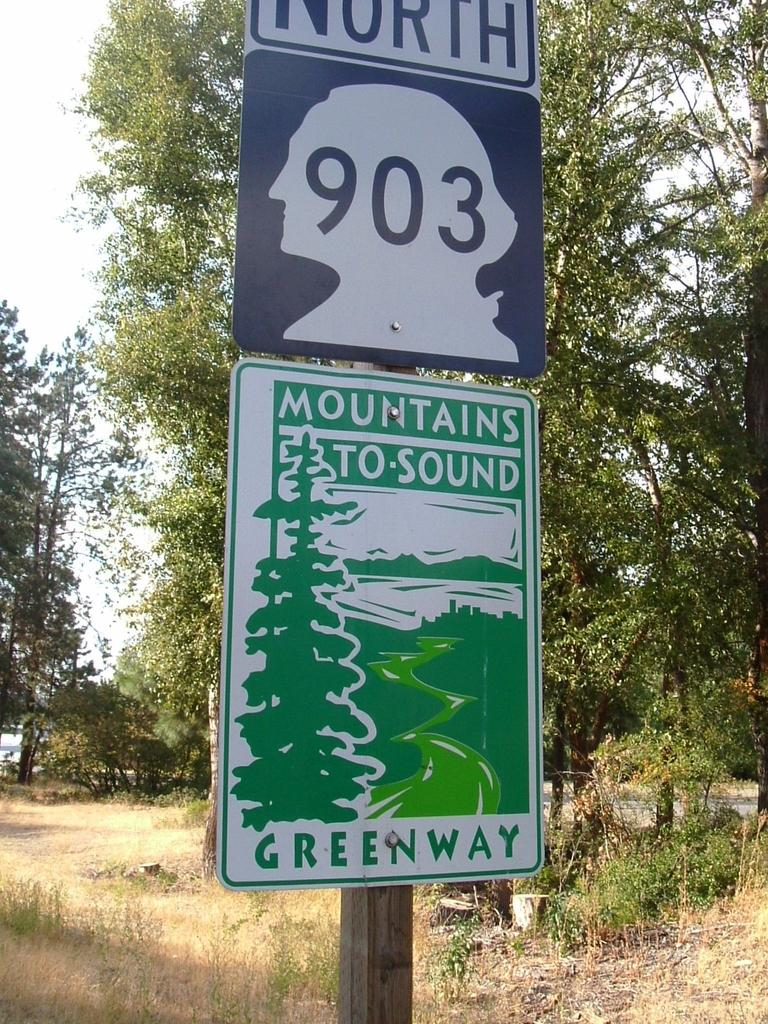What is attached to the pole in the image? There are name boards attached to a pole in the image. What can be seen in the background of the image? The ground, plants, trees, and the sky are visible in the background of the image. What type of boats are being used for the feast in the image? There is no mention of boats or a feast in the image; it features name boards attached to a pole and a background with the ground, plants, trees, and the sky. 